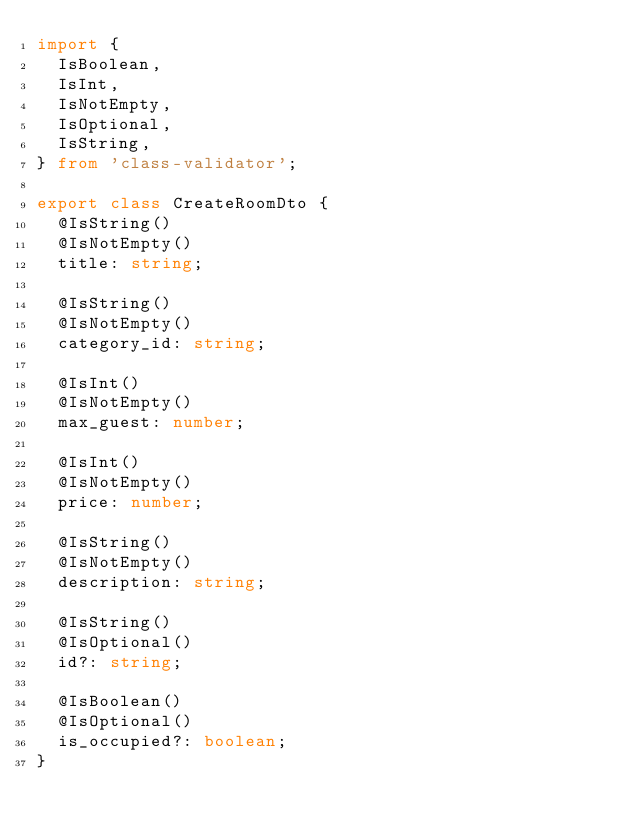Convert code to text. <code><loc_0><loc_0><loc_500><loc_500><_TypeScript_>import {
  IsBoolean,
  IsInt,
  IsNotEmpty,
  IsOptional,
  IsString,
} from 'class-validator';

export class CreateRoomDto {
  @IsString()
  @IsNotEmpty()
  title: string;

  @IsString()
  @IsNotEmpty()
  category_id: string;

  @IsInt()
  @IsNotEmpty()
  max_guest: number;

  @IsInt()
  @IsNotEmpty()
  price: number;

  @IsString()
  @IsNotEmpty()
  description: string;

  @IsString()
  @IsOptional()
  id?: string;

  @IsBoolean()
  @IsOptional()
  is_occupied?: boolean;
}
</code> 